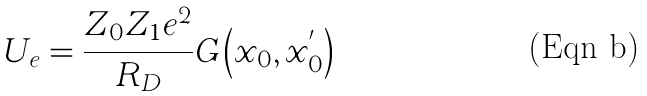<formula> <loc_0><loc_0><loc_500><loc_500>U _ { e } = \frac { Z _ { 0 } Z _ { 1 } e ^ { 2 } } { R _ { D } } G \left ( x _ { 0 } , x _ { 0 } ^ { ^ { \prime } } \right )</formula> 